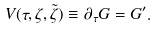<formula> <loc_0><loc_0><loc_500><loc_500>V ( \tau , \zeta , \tilde { \zeta } ) \equiv \partial _ { \tau } G = G ^ { \prime } .</formula> 